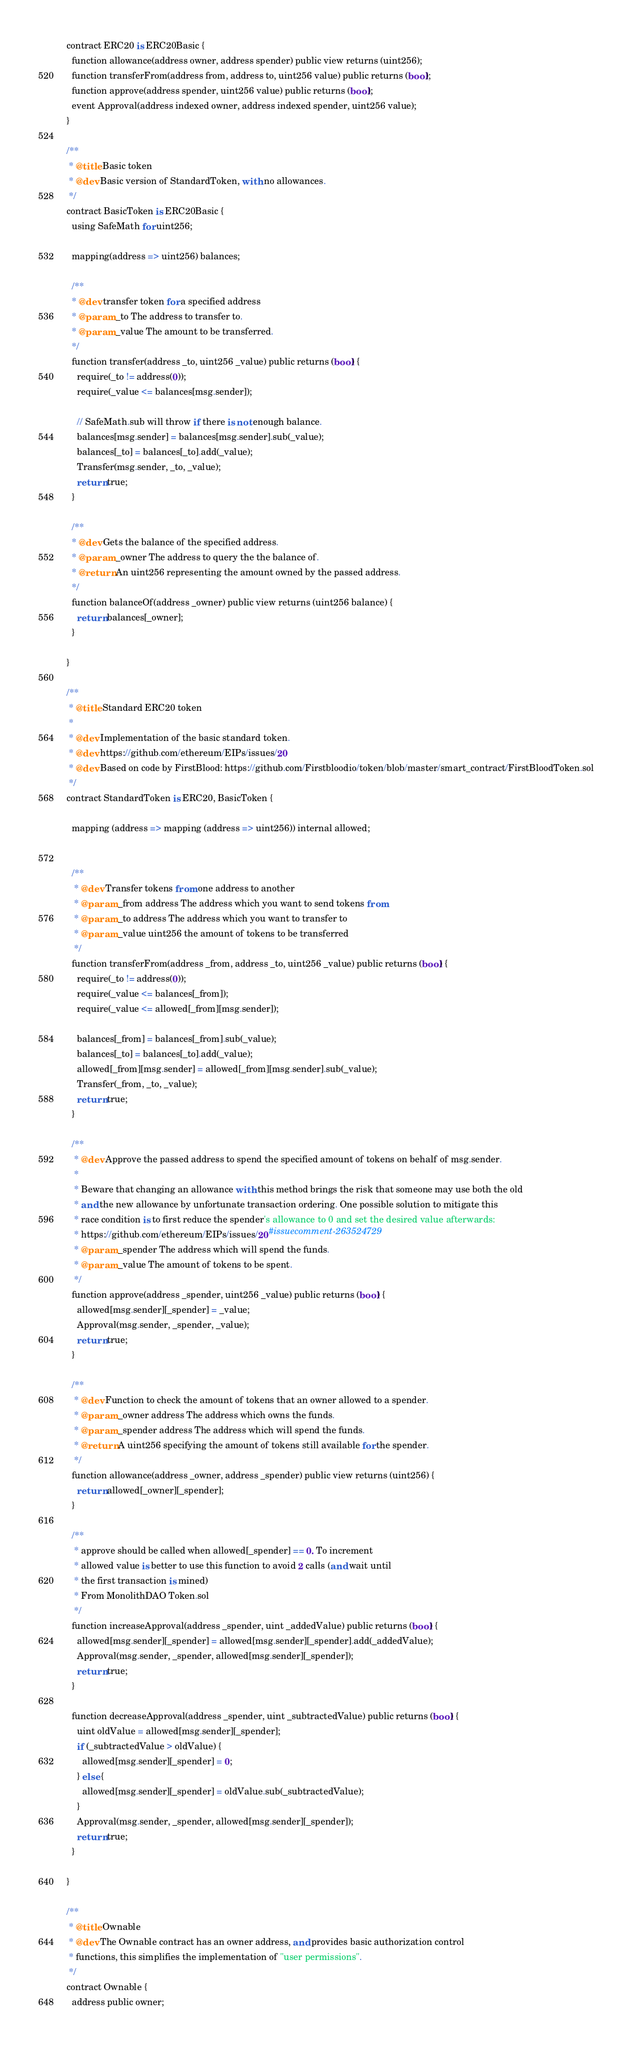<code> <loc_0><loc_0><loc_500><loc_500><_Python_>contract ERC20 is ERC20Basic {
  function allowance(address owner, address spender) public view returns (uint256);
  function transferFrom(address from, address to, uint256 value) public returns (bool);
  function approve(address spender, uint256 value) public returns (bool);
  event Approval(address indexed owner, address indexed spender, uint256 value);
}

/**
 * @title Basic token
 * @dev Basic version of StandardToken, with no allowances.
 */
contract BasicToken is ERC20Basic {
  using SafeMath for uint256;

  mapping(address => uint256) balances;

  /**
  * @dev transfer token for a specified address
  * @param _to The address to transfer to.
  * @param _value The amount to be transferred.
  */
  function transfer(address _to, uint256 _value) public returns (bool) {
    require(_to != address(0));
    require(_value <= balances[msg.sender]);

    // SafeMath.sub will throw if there is not enough balance.
    balances[msg.sender] = balances[msg.sender].sub(_value);
    balances[_to] = balances[_to].add(_value);
    Transfer(msg.sender, _to, _value);
    return true;
  }

  /**
  * @dev Gets the balance of the specified address.
  * @param _owner The address to query the the balance of.
  * @return An uint256 representing the amount owned by the passed address.
  */
  function balanceOf(address _owner) public view returns (uint256 balance) {
    return balances[_owner];
  }

}

/**
 * @title Standard ERC20 token
 *
 * @dev Implementation of the basic standard token.
 * @dev https://github.com/ethereum/EIPs/issues/20
 * @dev Based on code by FirstBlood: https://github.com/Firstbloodio/token/blob/master/smart_contract/FirstBloodToken.sol
 */
contract StandardToken is ERC20, BasicToken {

  mapping (address => mapping (address => uint256)) internal allowed;


  /**
   * @dev Transfer tokens from one address to another
   * @param _from address The address which you want to send tokens from
   * @param _to address The address which you want to transfer to
   * @param _value uint256 the amount of tokens to be transferred
   */
  function transferFrom(address _from, address _to, uint256 _value) public returns (bool) {
    require(_to != address(0));
    require(_value <= balances[_from]);
    require(_value <= allowed[_from][msg.sender]);

    balances[_from] = balances[_from].sub(_value);
    balances[_to] = balances[_to].add(_value);
    allowed[_from][msg.sender] = allowed[_from][msg.sender].sub(_value);
    Transfer(_from, _to, _value);
    return true;
  }

  /**
   * @dev Approve the passed address to spend the specified amount of tokens on behalf of msg.sender.
   *
   * Beware that changing an allowance with this method brings the risk that someone may use both the old
   * and the new allowance by unfortunate transaction ordering. One possible solution to mitigate this
   * race condition is to first reduce the spender's allowance to 0 and set the desired value afterwards:
   * https://github.com/ethereum/EIPs/issues/20#issuecomment-263524729
   * @param _spender The address which will spend the funds.
   * @param _value The amount of tokens to be spent.
   */
  function approve(address _spender, uint256 _value) public returns (bool) {
    allowed[msg.sender][_spender] = _value;
    Approval(msg.sender, _spender, _value);
    return true;
  }

  /**
   * @dev Function to check the amount of tokens that an owner allowed to a spender.
   * @param _owner address The address which owns the funds.
   * @param _spender address The address which will spend the funds.
   * @return A uint256 specifying the amount of tokens still available for the spender.
   */
  function allowance(address _owner, address _spender) public view returns (uint256) {
    return allowed[_owner][_spender];
  }

  /**
   * approve should be called when allowed[_spender] == 0. To increment
   * allowed value is better to use this function to avoid 2 calls (and wait until
   * the first transaction is mined)
   * From MonolithDAO Token.sol
   */
  function increaseApproval(address _spender, uint _addedValue) public returns (bool) {
    allowed[msg.sender][_spender] = allowed[msg.sender][_spender].add(_addedValue);
    Approval(msg.sender, _spender, allowed[msg.sender][_spender]);
    return true;
  }

  function decreaseApproval(address _spender, uint _subtractedValue) public returns (bool) {
    uint oldValue = allowed[msg.sender][_spender];
    if (_subtractedValue > oldValue) {
      allowed[msg.sender][_spender] = 0;
    } else {
      allowed[msg.sender][_spender] = oldValue.sub(_subtractedValue);
    }
    Approval(msg.sender, _spender, allowed[msg.sender][_spender]);
    return true;
  }

}

/**
 * @title Ownable
 * @dev The Ownable contract has an owner address, and provides basic authorization control
 * functions, this simplifies the implementation of "user permissions".
 */
contract Ownable {
  address public owner;

</code> 